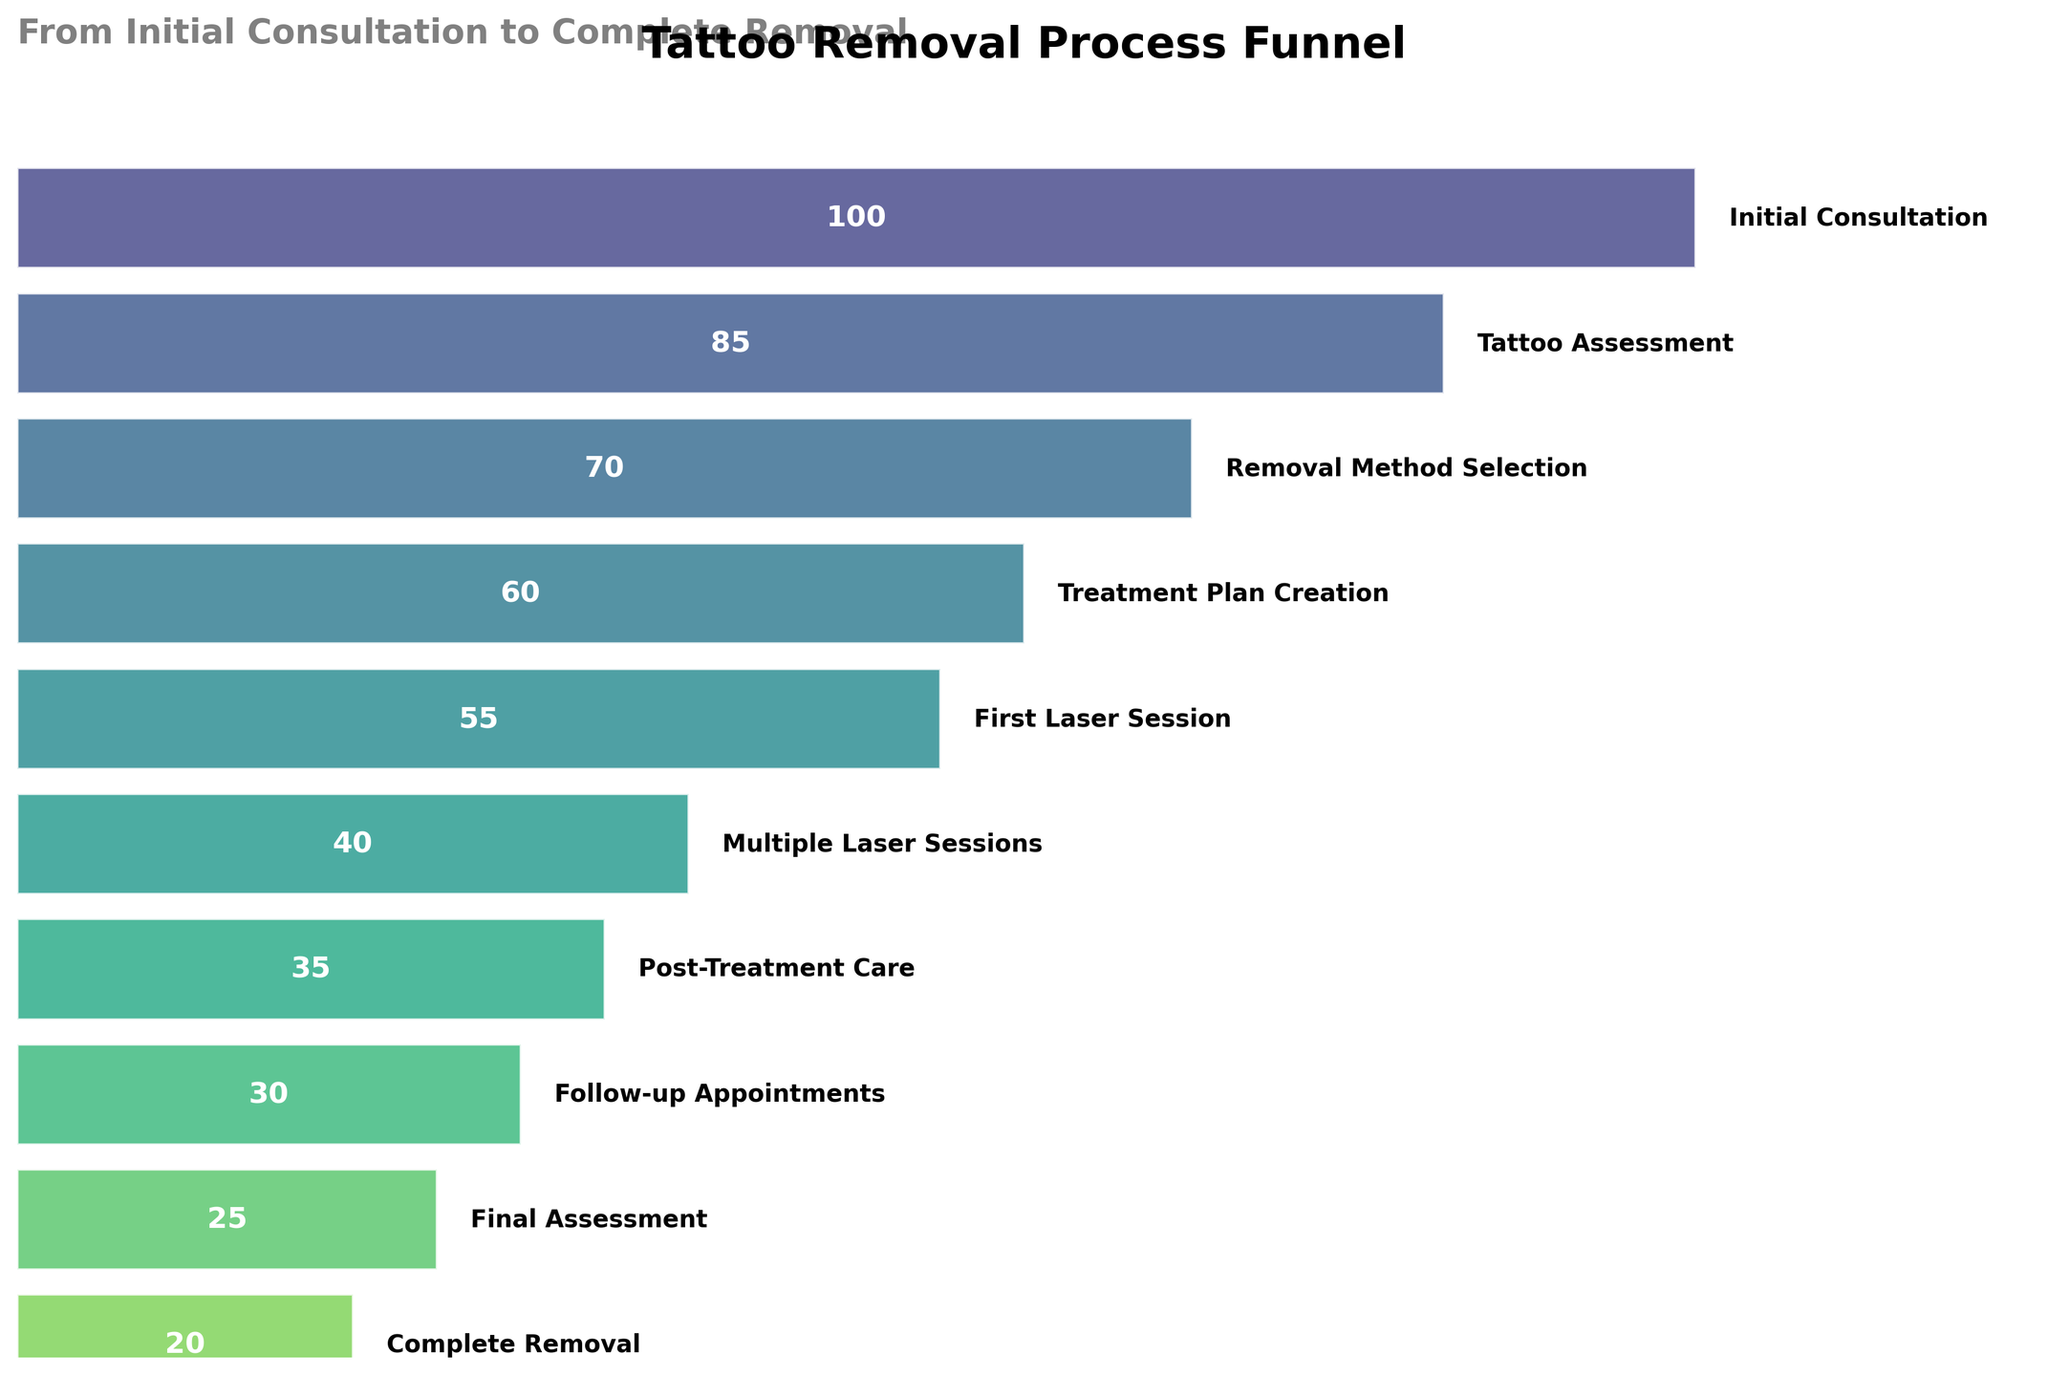Which step has the highest number of clients? The initial step in the funnel chart that has the largest width is the "Initial Consultation" step. This indicates the highest number of clients at this stage.
Answer: Initial Consultation Which step has the lowest number of clients? The final step in the funnel chart with the smallest width is the "Complete Removal" step. This indicates the lowest number of clients at this stage.
Answer: Complete Removal What is the title of the funnel chart? The title of the funnel chart is displayed at the top of the figure.
Answer: Tattoo Removal Process Funnel How many clients move from 'Removal Method Selection' to 'Treatment Plan Creation'? To find this, look at the number of clients for the "Removal Method Selection" step and the "Treatment Plan Creation" step. The difference between them indicates how many clients moved on. 70 - 60 = 10 clients move on to the next step.
Answer: 10 Which steps see the largest drop in client numbers? The largest drop can be identified by comparing the differences in client numbers between consecutive steps. The largest difference is between "First Laser Session" (55) and "Multiple Laser Sessions" (40), which is 55 - 40 = 15.
Answer: First Laser Session to Multiple Laser Sessions What is the total number of clients from the 'First Laser Session' until 'Complete Removal'? To get the total number of clients, sum up the client numbers from the "First Laser Session" through to "Complete Removal". This includes 55 (First Laser Session) + 40 (Multiple Laser Sessions) + 35 (Post-Treatment Care) + 30 (Follow-up Appointments) + 25 (Final Assessment) + 20 (Complete Removal) = 205
Answer: 205 Which step shows a smaller drop right after 'Post-Treatment Care', 'Post-Treatment Care' or 'Follow-up Appointments'? Compare the difference in client numbers for steps after "Post-Treatment Care" and "Follow-up Appointments." "Post-Treatment Care" has 35 clients, and the next step "Follow-up Appointments" has 30 clients (drop by 5). "Follow-up Appointments" has 30 clients, and the next step "Final Assessment" has 25 clients (drop by 5). Both drops are 5 clients, so they are equal.
Answer: Equal What is the average number of clients from 'Initial Consultation' to 'First Laser Session'? Sum the client numbers from "Initial Consultation" to "First Laser Session" and divide by the number of steps. (100 + 85 + 70 + 60 + 55) / 5 = 370 / 5 = 74
Answer: 74 How many steps are listed in the funnel chart? Count the total number of steps listed vertically in the funnel chart.
Answer: 10 How many more clients are there in the 'Tattoo Assessment' step compared to the 'Follow-up Appointments' step? Compare the number of clients in "Tattoo Assessment" (85) and "Follow-up Appointments" (30). The difference is 85 - 30 = 55 more clients.
Answer: 55 